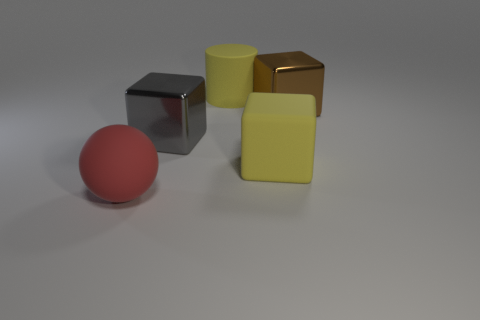Subtract all yellow rubber cubes. How many cubes are left? 2 Add 4 purple objects. How many objects exist? 9 Subtract all spheres. How many objects are left? 4 Subtract 0 cyan balls. How many objects are left? 5 Subtract all big cyan matte cylinders. Subtract all large cylinders. How many objects are left? 4 Add 2 brown things. How many brown things are left? 3 Add 2 large gray shiny cubes. How many large gray shiny cubes exist? 3 